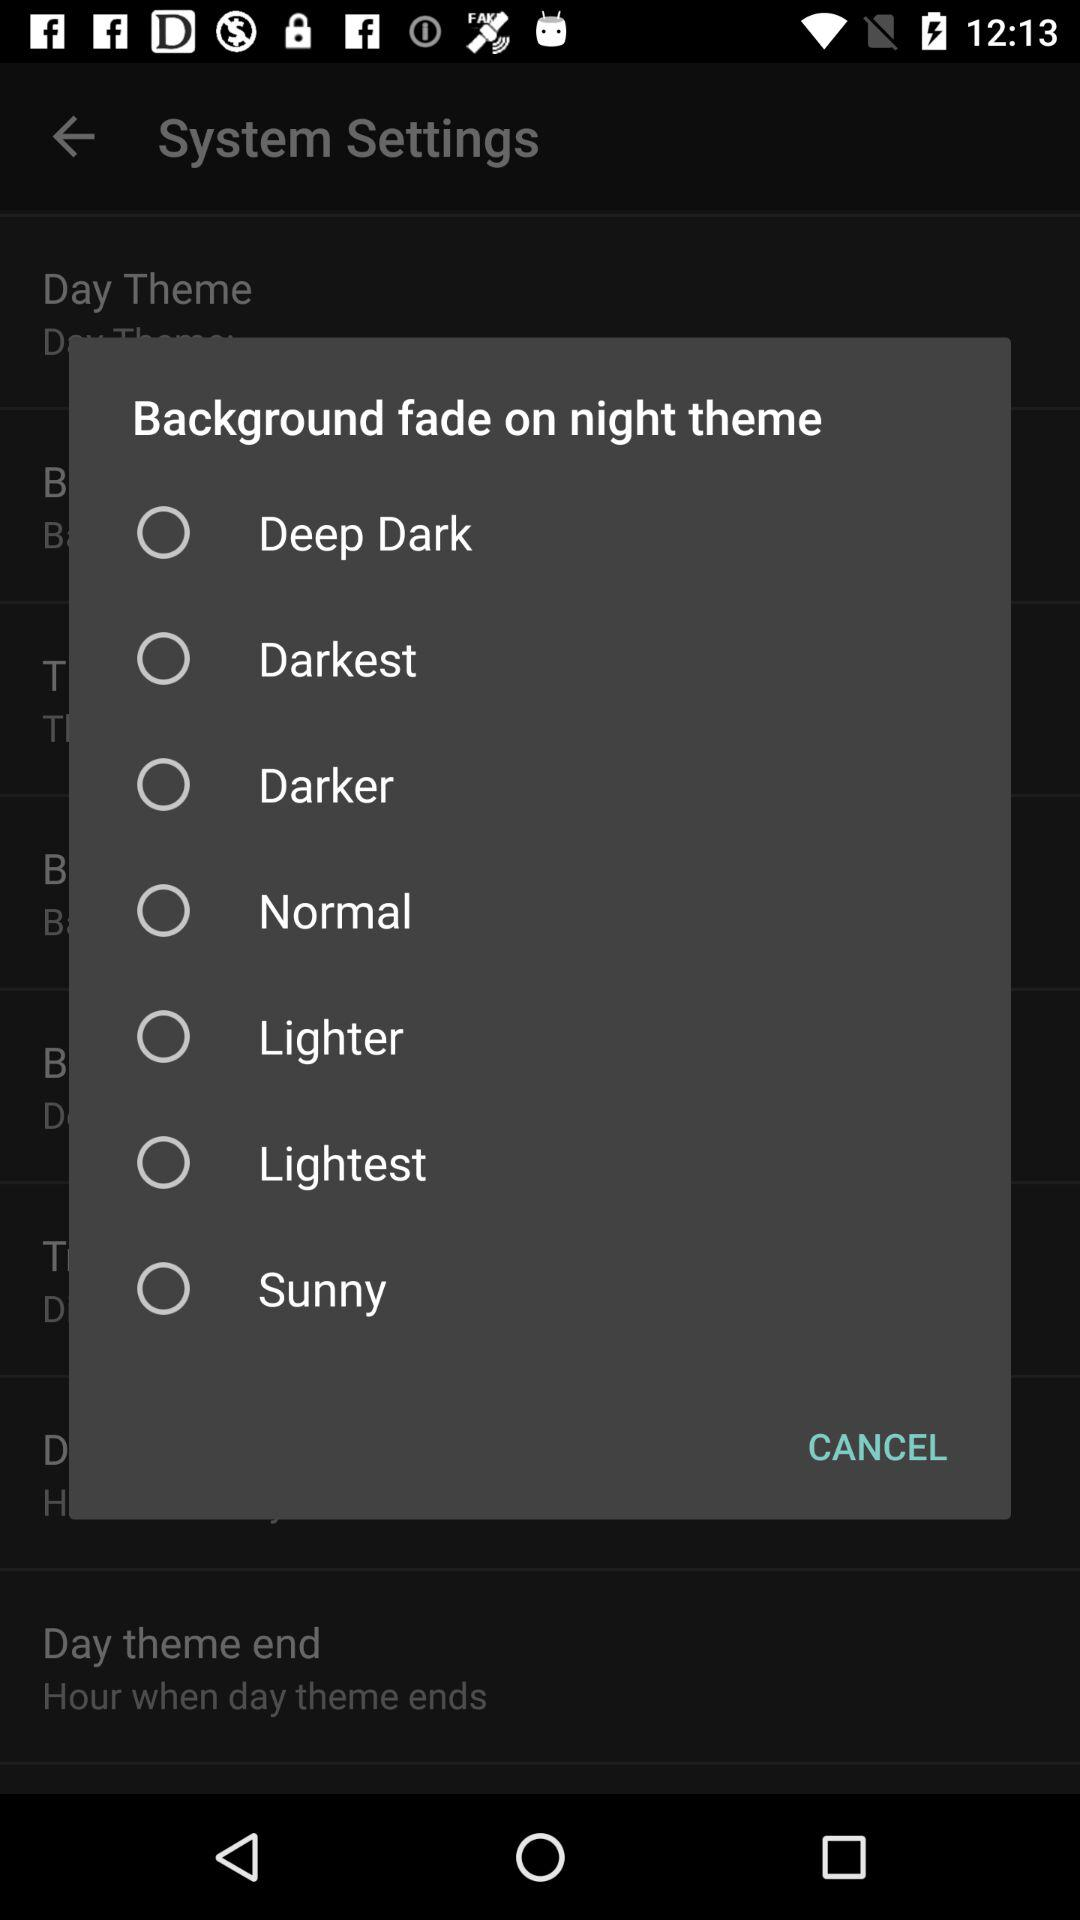How many levels of background fade options are there?
Answer the question using a single word or phrase. 7 